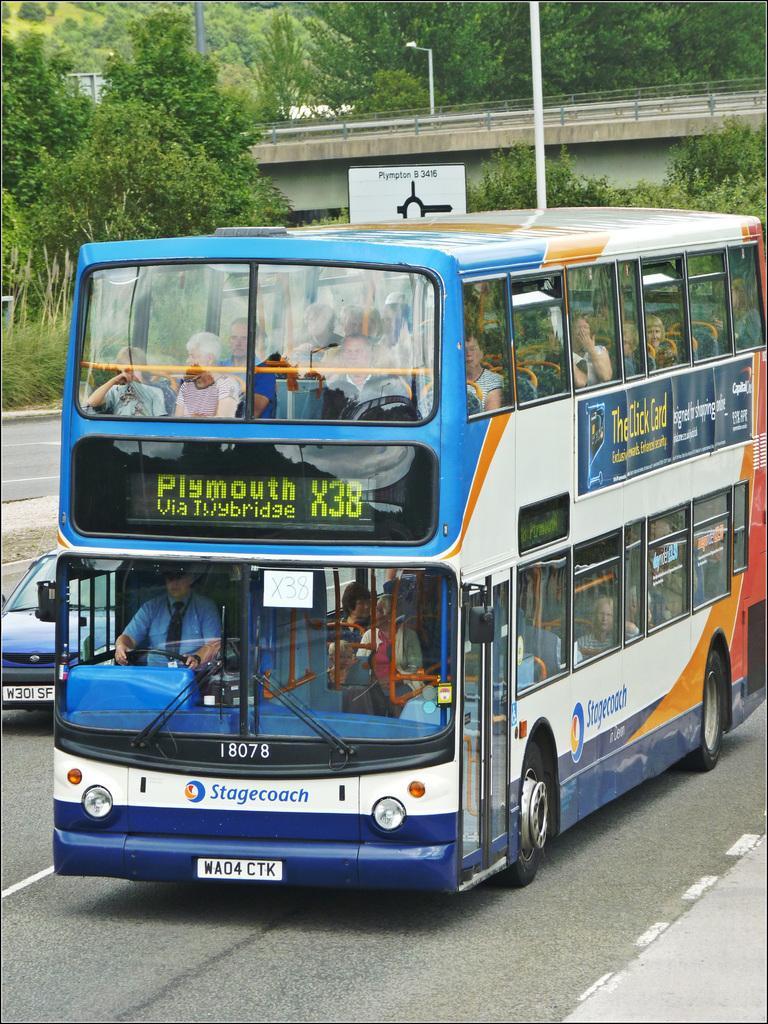Please provide a concise description of this image. In this image we can see a group of people sitting in a bus which is on the road. We can also see a car beside it. On the backside we can see a signboard with some text on it, some poles, a group of trees, grass, a street pole and a bridge. 